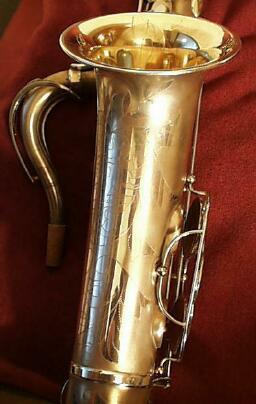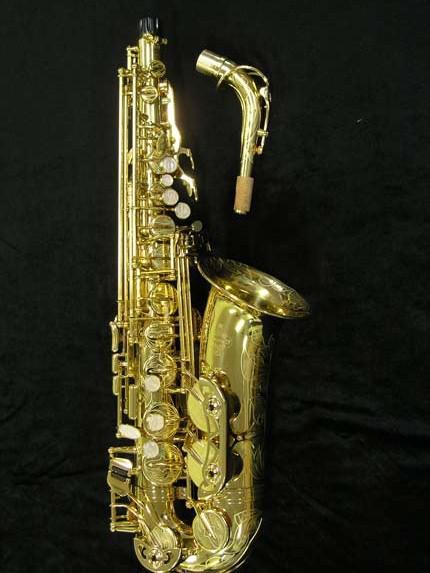The first image is the image on the left, the second image is the image on the right. Assess this claim about the two images: "All of the instruments are facing the same direction.". Correct or not? Answer yes or no. No. The first image is the image on the left, the second image is the image on the right. Assess this claim about the two images: "The image on the right has a solid black background.". Correct or not? Answer yes or no. Yes. 